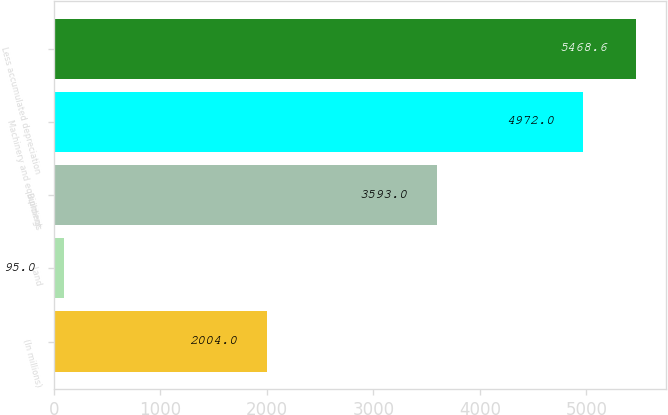<chart> <loc_0><loc_0><loc_500><loc_500><bar_chart><fcel>(In millions)<fcel>Land<fcel>Buildings<fcel>Machinery and equipment<fcel>Less accumulated depreciation<nl><fcel>2004<fcel>95<fcel>3593<fcel>4972<fcel>5468.6<nl></chart> 